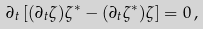<formula> <loc_0><loc_0><loc_500><loc_500>\partial _ { t } \left [ ( \partial _ { t } \zeta ) \zeta ^ { * } - ( \partial _ { t } \zeta ^ { * } ) \zeta \right ] = 0 \, ,</formula> 